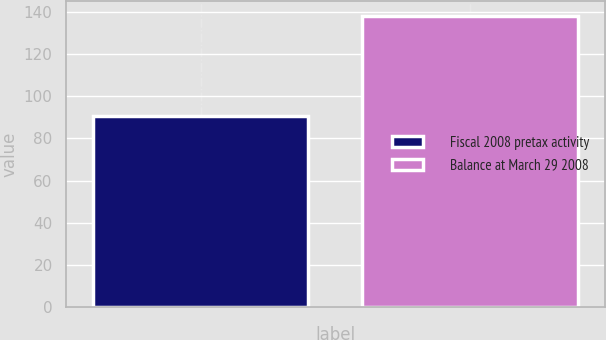Convert chart to OTSL. <chart><loc_0><loc_0><loc_500><loc_500><bar_chart><fcel>Fiscal 2008 pretax activity<fcel>Balance at March 29 2008<nl><fcel>90.8<fcel>138.1<nl></chart> 